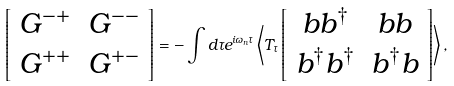<formula> <loc_0><loc_0><loc_500><loc_500>\left [ \begin{array} { c c } G ^ { - + } & G ^ { - - } \\ G ^ { + + } & G ^ { + - } \end{array} \right ] = - \int d \tau e ^ { i \omega _ { n } \tau } \left \langle T _ { \tau } \left [ \begin{array} { c c } b b ^ { \dagger } & b b \\ b ^ { \dagger } b ^ { \dagger } & b ^ { \dagger } b \end{array} \right ] \right \rangle ,</formula> 